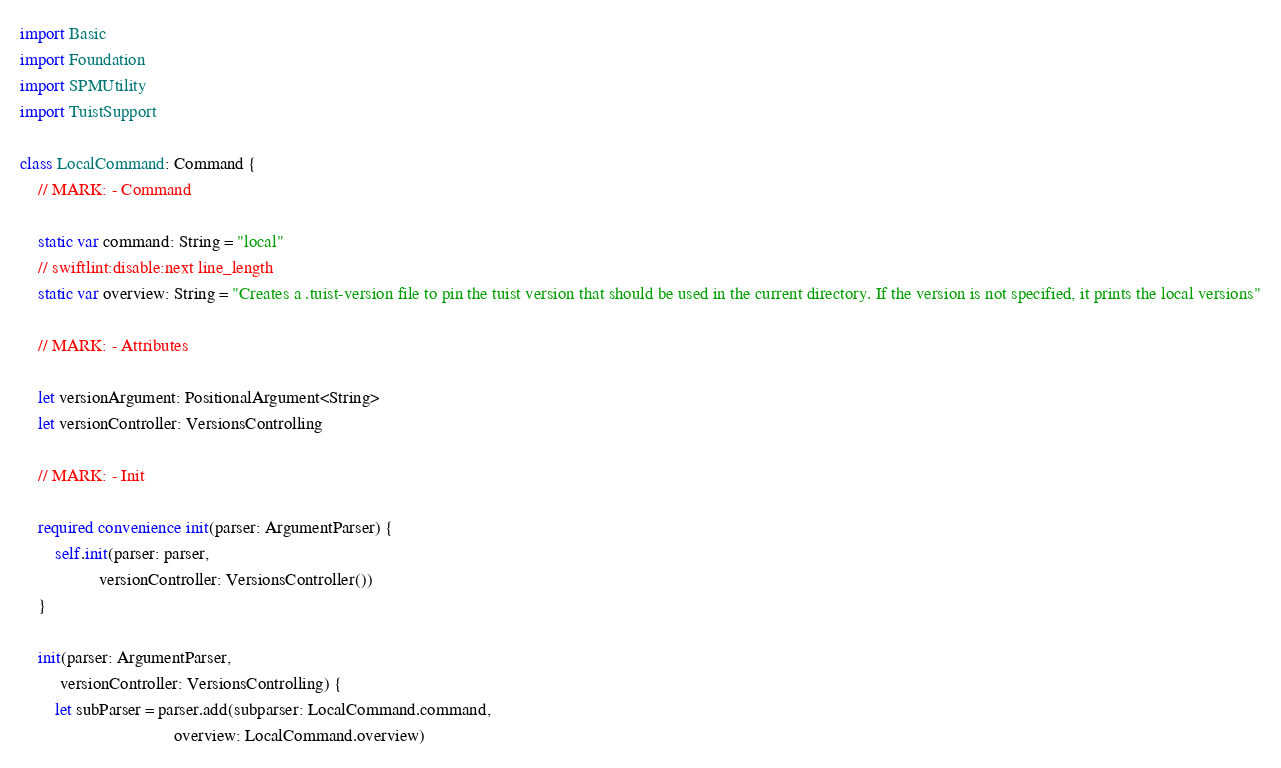Convert code to text. <code><loc_0><loc_0><loc_500><loc_500><_Swift_>import Basic
import Foundation
import SPMUtility
import TuistSupport

class LocalCommand: Command {
    // MARK: - Command

    static var command: String = "local"
    // swiftlint:disable:next line_length
    static var overview: String = "Creates a .tuist-version file to pin the tuist version that should be used in the current directory. If the version is not specified, it prints the local versions"

    // MARK: - Attributes

    let versionArgument: PositionalArgument<String>
    let versionController: VersionsControlling

    // MARK: - Init

    required convenience init(parser: ArgumentParser) {
        self.init(parser: parser,
                  versionController: VersionsController())
    }

    init(parser: ArgumentParser,
         versionController: VersionsControlling) {
        let subParser = parser.add(subparser: LocalCommand.command,
                                   overview: LocalCommand.overview)</code> 